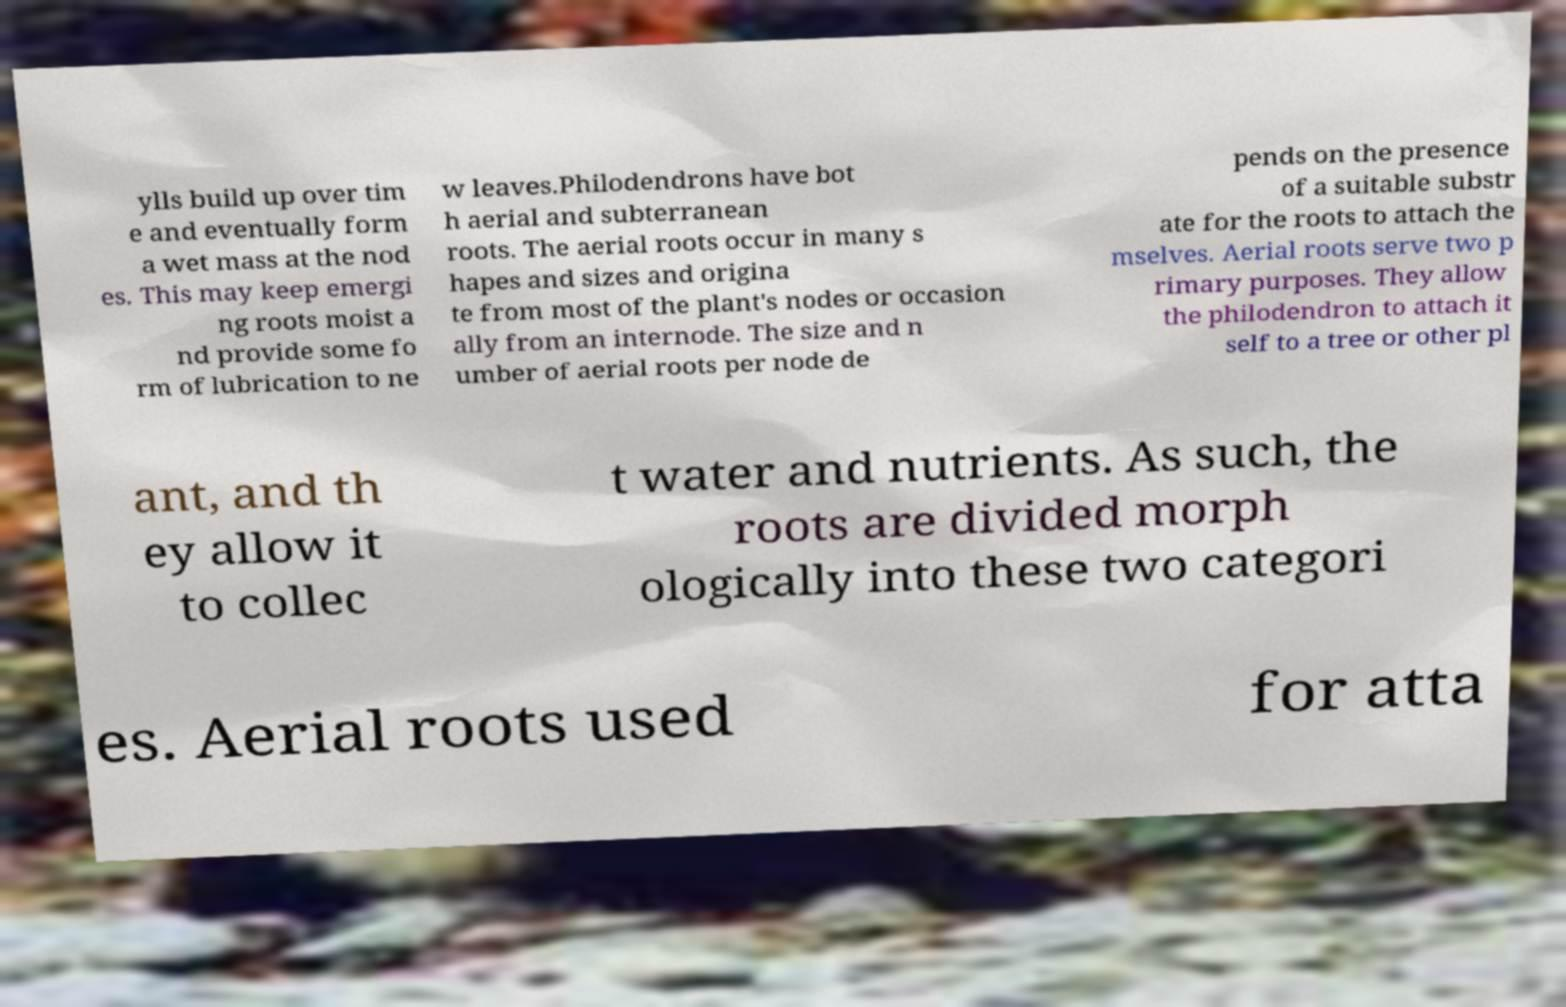I need the written content from this picture converted into text. Can you do that? ylls build up over tim e and eventually form a wet mass at the nod es. This may keep emergi ng roots moist a nd provide some fo rm of lubrication to ne w leaves.Philodendrons have bot h aerial and subterranean roots. The aerial roots occur in many s hapes and sizes and origina te from most of the plant's nodes or occasion ally from an internode. The size and n umber of aerial roots per node de pends on the presence of a suitable substr ate for the roots to attach the mselves. Aerial roots serve two p rimary purposes. They allow the philodendron to attach it self to a tree or other pl ant, and th ey allow it to collec t water and nutrients. As such, the roots are divided morph ologically into these two categori es. Aerial roots used for atta 